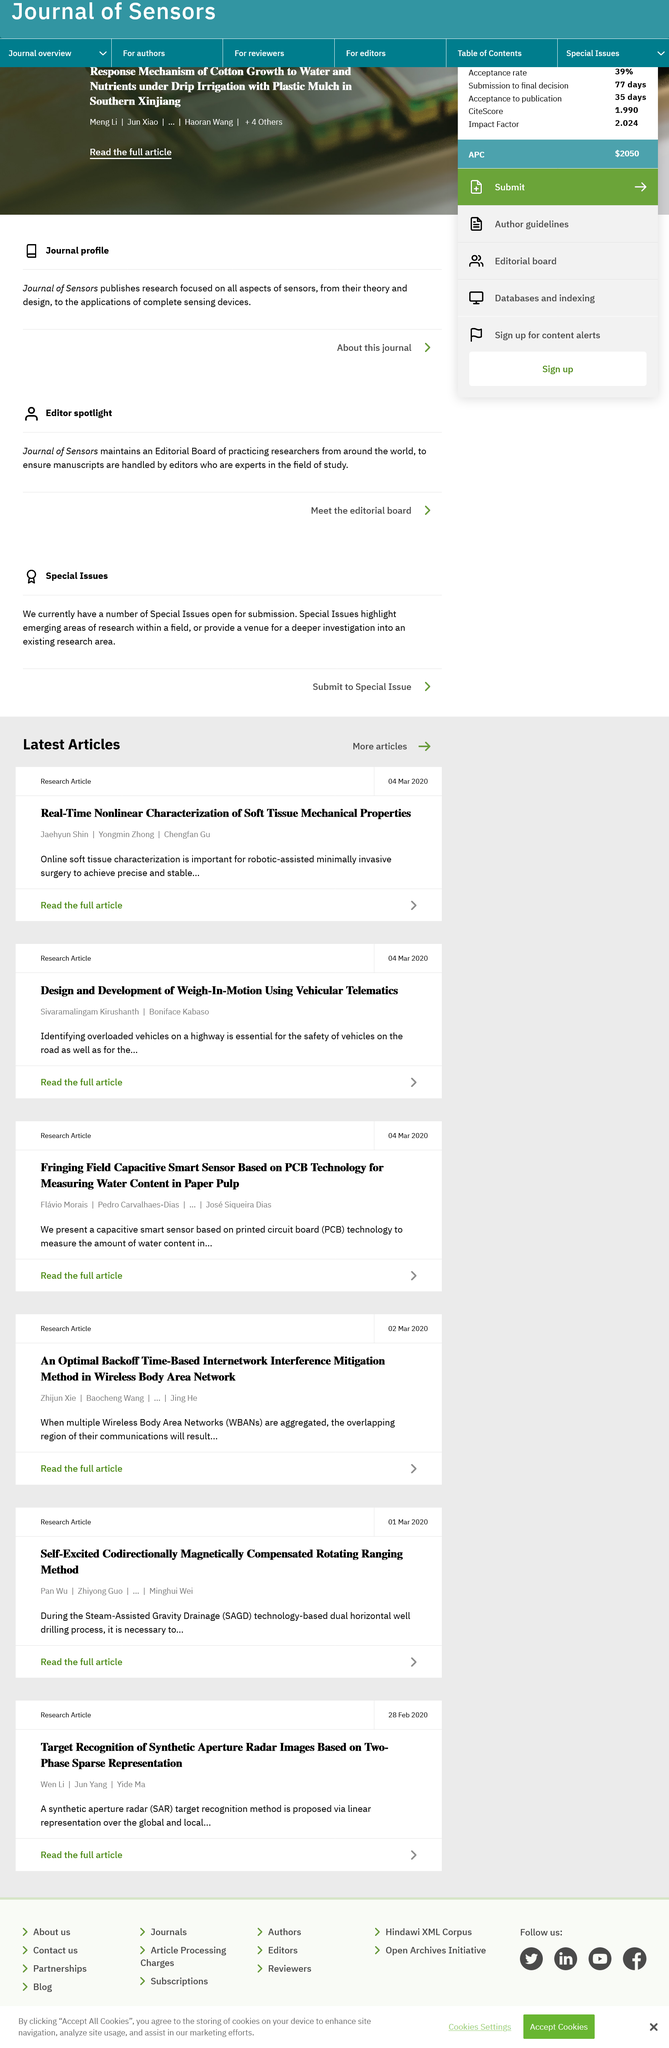Point out several critical features in this image. On March 4th, 2020, the research article "Design and Development of Weigh-in-motion using Vehicular Telematics" was published. The authors of the article "Real-Time Nonlinear Characterization of Soft Tissue Mechanical Properties" are Jaehyun Shin, Yongmin Zhong, and Chengfan Gu. Online soft tissue characterization is essential for robotic-assisted minimally invasive surgery, as it enables surgeons to precisely identify and locate soft tissue structures during surgical procedures, thereby improving surgical accuracy and reducing the risk of complications. 